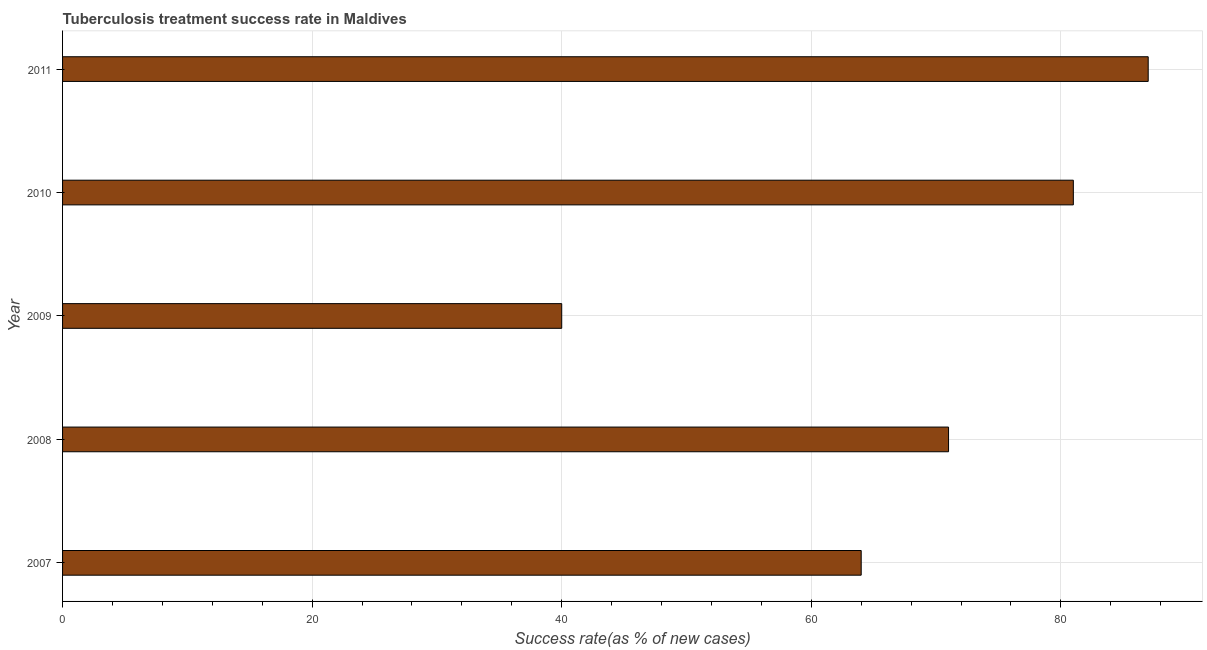Does the graph contain any zero values?
Provide a succinct answer. No. Does the graph contain grids?
Give a very brief answer. Yes. What is the title of the graph?
Keep it short and to the point. Tuberculosis treatment success rate in Maldives. What is the label or title of the X-axis?
Your answer should be compact. Success rate(as % of new cases). What is the label or title of the Y-axis?
Provide a short and direct response. Year. What is the tuberculosis treatment success rate in 2008?
Provide a succinct answer. 71. In which year was the tuberculosis treatment success rate minimum?
Give a very brief answer. 2009. What is the sum of the tuberculosis treatment success rate?
Make the answer very short. 343. What is the average tuberculosis treatment success rate per year?
Your answer should be very brief. 68. What is the median tuberculosis treatment success rate?
Ensure brevity in your answer.  71. Do a majority of the years between 2008 and 2009 (inclusive) have tuberculosis treatment success rate greater than 64 %?
Provide a short and direct response. No. Is the difference between the tuberculosis treatment success rate in 2009 and 2011 greater than the difference between any two years?
Ensure brevity in your answer.  Yes. Is the sum of the tuberculosis treatment success rate in 2007 and 2008 greater than the maximum tuberculosis treatment success rate across all years?
Your answer should be compact. Yes. How many bars are there?
Your response must be concise. 5. Are all the bars in the graph horizontal?
Your answer should be very brief. Yes. How many years are there in the graph?
Offer a very short reply. 5. What is the Success rate(as % of new cases) of 2008?
Give a very brief answer. 71. What is the Success rate(as % of new cases) of 2011?
Keep it short and to the point. 87. What is the difference between the Success rate(as % of new cases) in 2007 and 2009?
Give a very brief answer. 24. What is the difference between the Success rate(as % of new cases) in 2007 and 2010?
Your answer should be very brief. -17. What is the difference between the Success rate(as % of new cases) in 2007 and 2011?
Offer a very short reply. -23. What is the difference between the Success rate(as % of new cases) in 2008 and 2009?
Provide a succinct answer. 31. What is the difference between the Success rate(as % of new cases) in 2008 and 2011?
Your answer should be compact. -16. What is the difference between the Success rate(as % of new cases) in 2009 and 2010?
Your answer should be compact. -41. What is the difference between the Success rate(as % of new cases) in 2009 and 2011?
Ensure brevity in your answer.  -47. What is the ratio of the Success rate(as % of new cases) in 2007 to that in 2008?
Keep it short and to the point. 0.9. What is the ratio of the Success rate(as % of new cases) in 2007 to that in 2010?
Provide a short and direct response. 0.79. What is the ratio of the Success rate(as % of new cases) in 2007 to that in 2011?
Keep it short and to the point. 0.74. What is the ratio of the Success rate(as % of new cases) in 2008 to that in 2009?
Ensure brevity in your answer.  1.77. What is the ratio of the Success rate(as % of new cases) in 2008 to that in 2010?
Provide a short and direct response. 0.88. What is the ratio of the Success rate(as % of new cases) in 2008 to that in 2011?
Keep it short and to the point. 0.82. What is the ratio of the Success rate(as % of new cases) in 2009 to that in 2010?
Provide a succinct answer. 0.49. What is the ratio of the Success rate(as % of new cases) in 2009 to that in 2011?
Ensure brevity in your answer.  0.46. 